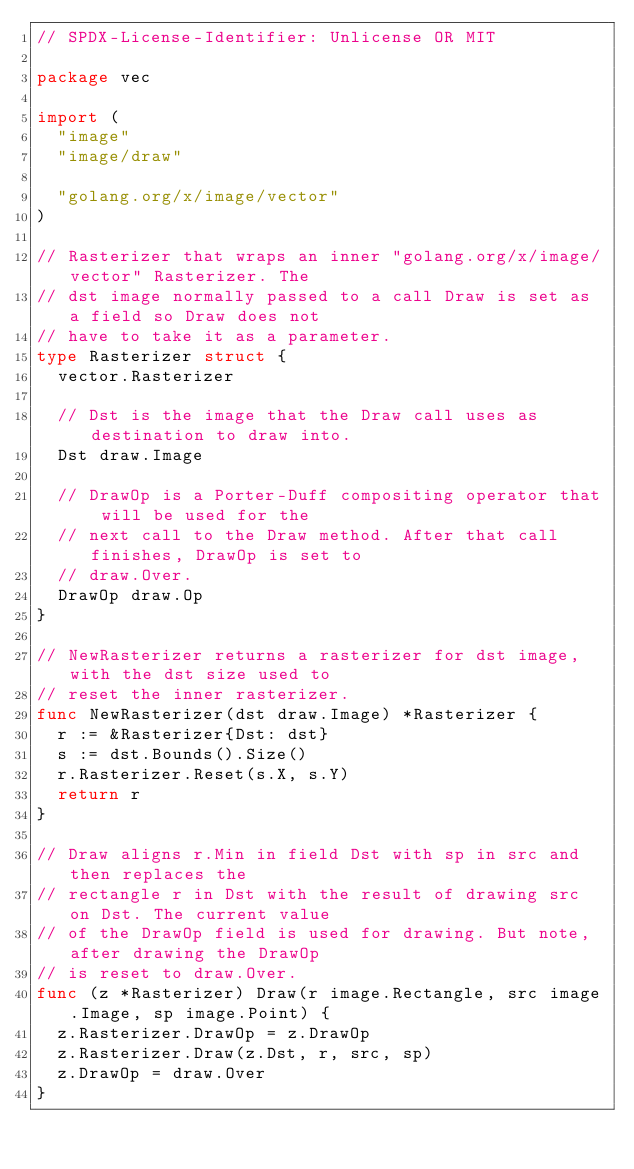<code> <loc_0><loc_0><loc_500><loc_500><_Go_>// SPDX-License-Identifier: Unlicense OR MIT

package vec

import (
	"image"
	"image/draw"

	"golang.org/x/image/vector"
)

// Rasterizer that wraps an inner "golang.org/x/image/vector" Rasterizer. The
// dst image normally passed to a call Draw is set as a field so Draw does not
// have to take it as a parameter.
type Rasterizer struct {
	vector.Rasterizer

	// Dst is the image that the Draw call uses as destination to draw into.
	Dst draw.Image

	// DrawOp is a Porter-Duff compositing operator that will be used for the
	// next call to the Draw method. After that call finishes, DrawOp is set to
	// draw.Over.
	DrawOp draw.Op
}

// NewRasterizer returns a rasterizer for dst image, with the dst size used to
// reset the inner rasterizer.
func NewRasterizer(dst draw.Image) *Rasterizer {
	r := &Rasterizer{Dst: dst}
	s := dst.Bounds().Size()
	r.Rasterizer.Reset(s.X, s.Y)
	return r
}

// Draw aligns r.Min in field Dst with sp in src and then replaces the
// rectangle r in Dst with the result of drawing src on Dst. The current value
// of the DrawOp field is used for drawing. But note, after drawing the DrawOp
// is reset to draw.Over.
func (z *Rasterizer) Draw(r image.Rectangle, src image.Image, sp image.Point) {
	z.Rasterizer.DrawOp = z.DrawOp
	z.Rasterizer.Draw(z.Dst, r, src, sp)
	z.DrawOp = draw.Over
}
</code> 